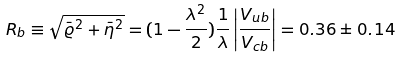Convert formula to latex. <formula><loc_0><loc_0><loc_500><loc_500>R _ { b } \equiv \sqrt { \bar { \varrho } ^ { 2 } + \bar { \eta } ^ { 2 } } = ( 1 - \frac { \lambda ^ { 2 } } { 2 } ) \frac { 1 } { \lambda } \left | \frac { V _ { u b } } { V _ { c b } } \right | = 0 . 3 6 \pm 0 . 1 4</formula> 